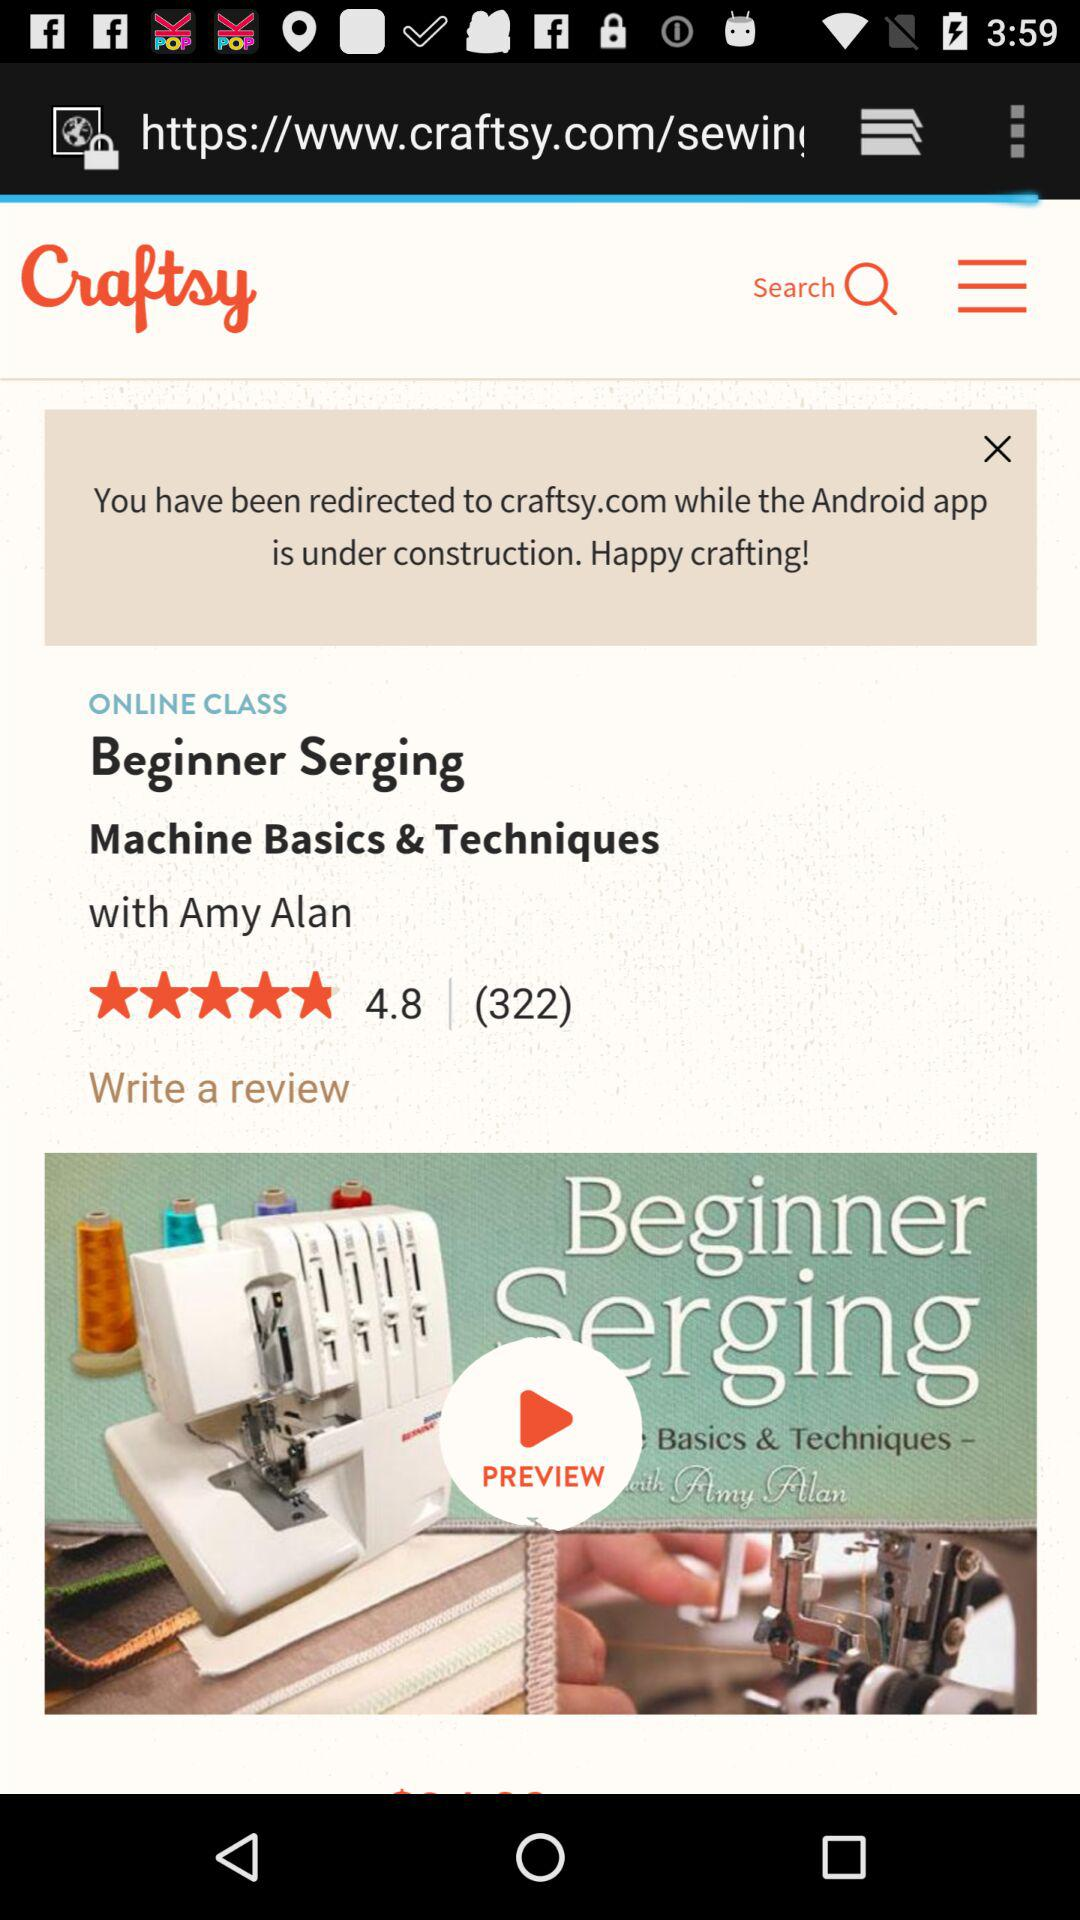Who is the mentor of "Machine Basics & Techniques"? The mentor is Amy Alan. 